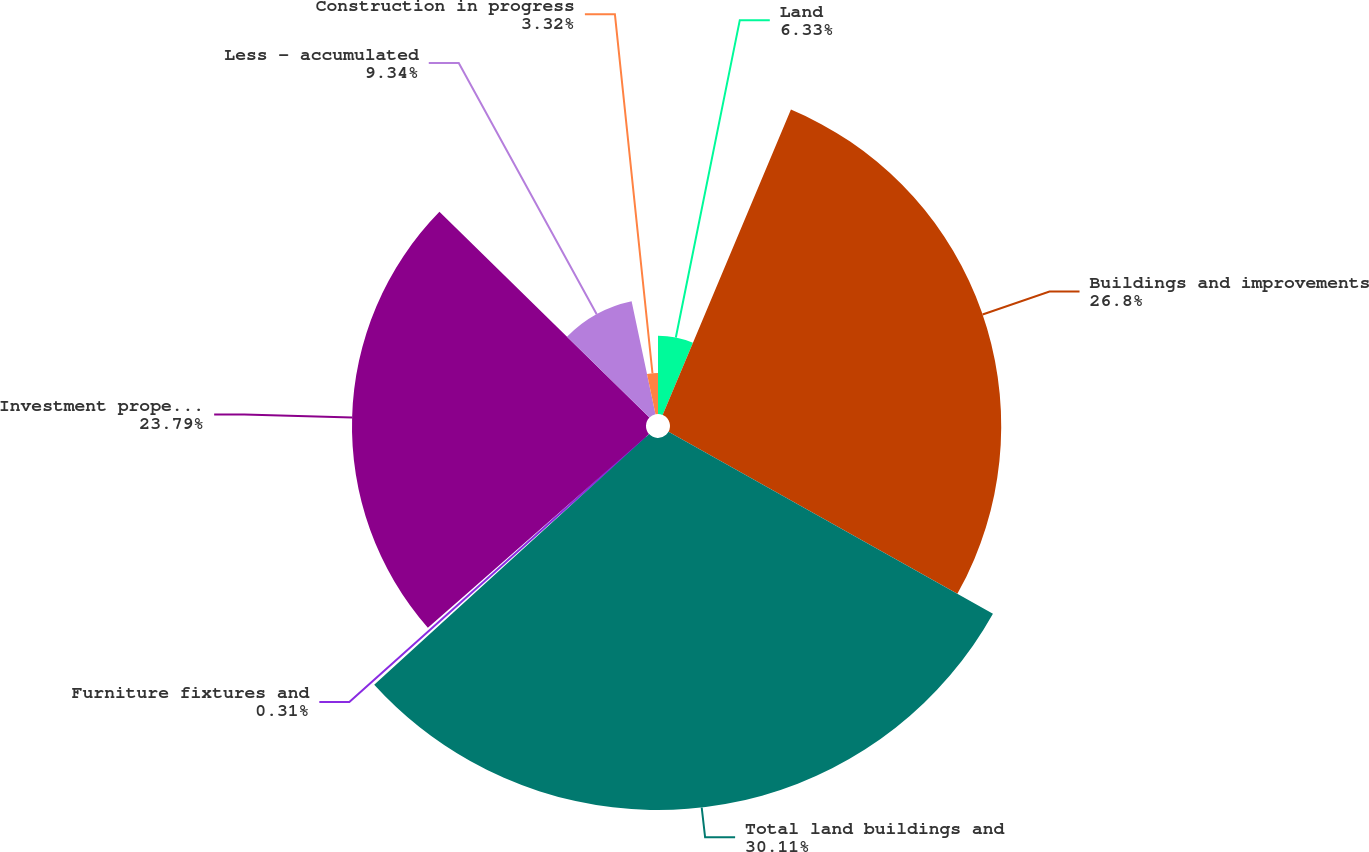Convert chart. <chart><loc_0><loc_0><loc_500><loc_500><pie_chart><fcel>Land<fcel>Buildings and improvements<fcel>Total land buildings and<fcel>Furniture fixtures and<fcel>Investment properties at cost<fcel>Less - accumulated<fcel>Construction in progress<nl><fcel>6.33%<fcel>26.8%<fcel>30.1%<fcel>0.31%<fcel>23.79%<fcel>9.34%<fcel>3.32%<nl></chart> 